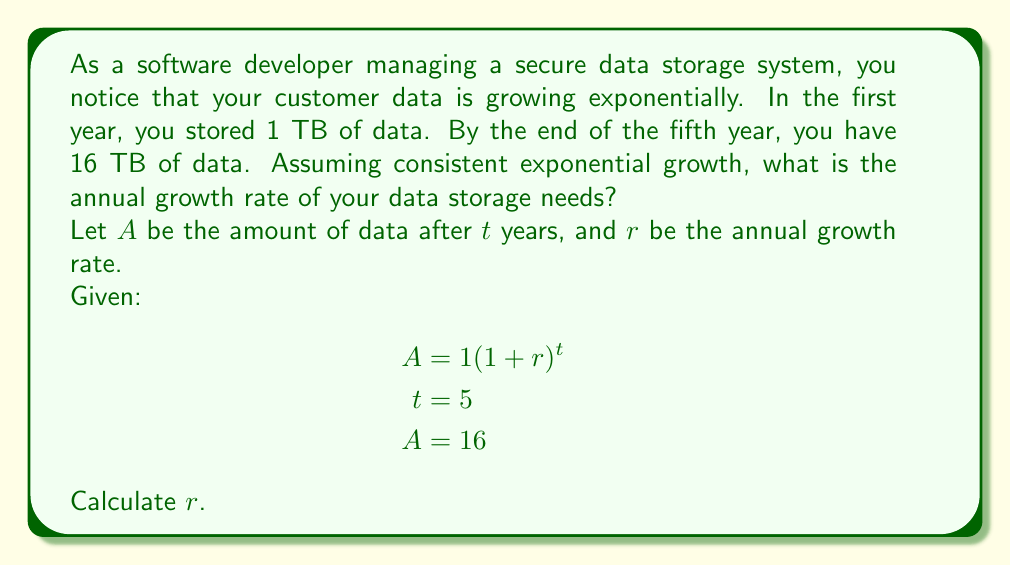Can you solve this math problem? To solve this problem, we'll use the exponential growth formula and solve for $r$:

1) Start with the exponential growth formula:
   $A = 1(1+r)^t$

2) Substitute the known values:
   $16 = 1(1+r)^5$

3) Simplify:
   $16 = (1+r)^5$

4) Take the fifth root of both sides:
   $\sqrt[5]{16} = 1+r$

5) Simplify the left side:
   $2 = 1+r$

6) Subtract 1 from both sides:
   $1 = r$

7) Convert to a percentage:
   $r = 1 = 100\%$

Therefore, the annual growth rate is 100%.

To verify:
Year 1: $1 \text{ TB}$
Year 2: $1 \cdot (1 + 1) = 2 \text{ TB}$
Year 3: $2 \cdot (1 + 1) = 4 \text{ TB}$
Year 4: $4 \cdot (1 + 1) = 8 \text{ TB}$
Year 5: $8 \cdot (1 + 1) = 16 \text{ TB}$

This confirms our calculated growth rate.
Answer: The annual growth rate of data storage needs is 100%. 